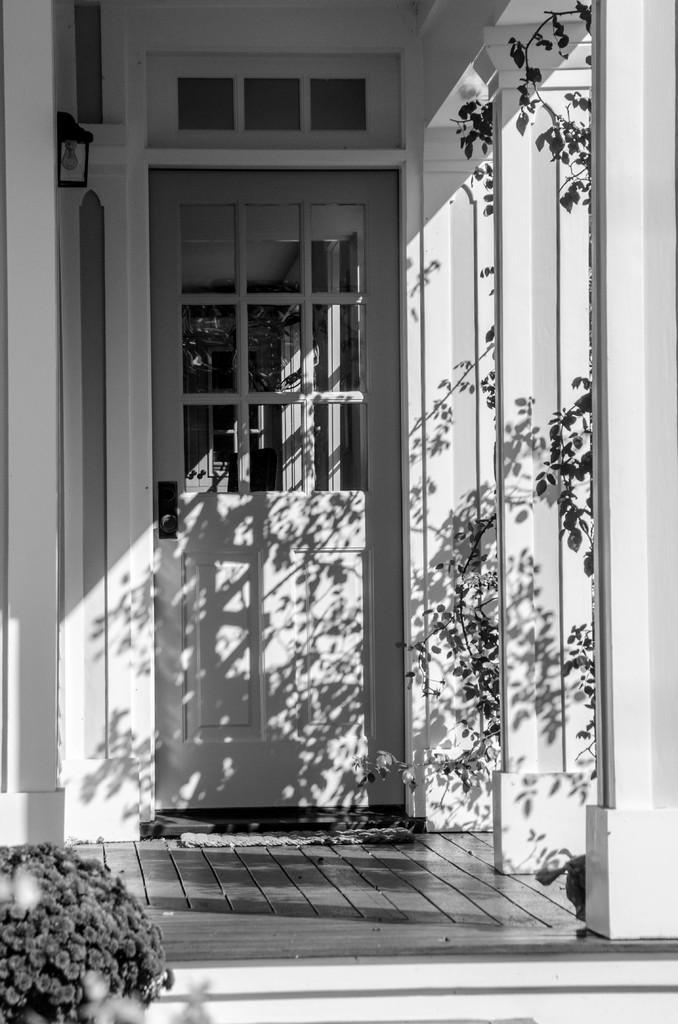In one or two sentences, can you explain what this image depicts? This is a black and white image. In this picture we can see some flowers on the left side. We can see a few plants on the right side. There is a building. We can see a door, a door handle and a few pillars. 